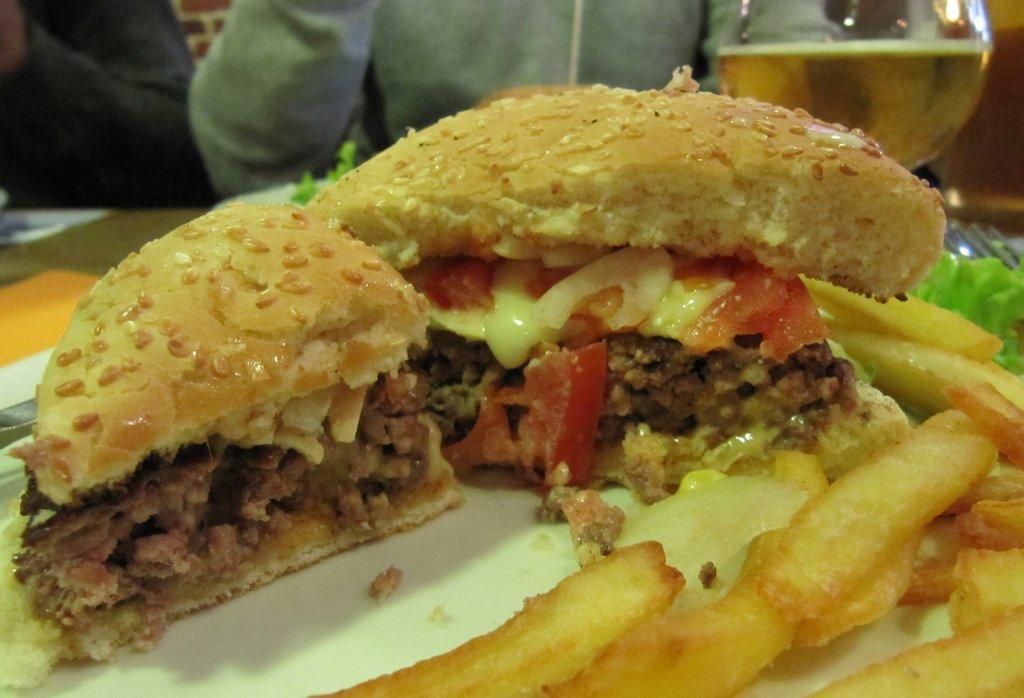In one or two sentences, can you explain what this image depicts? In this image we can see some food items and a glass with drink on the table and two persons near the table. 